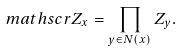Convert formula to latex. <formula><loc_0><loc_0><loc_500><loc_500>\ m a t h s c r { Z } _ { x } = \prod _ { y \in N ( x ) } Z _ { y } .</formula> 